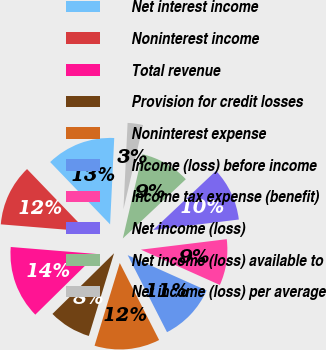<chart> <loc_0><loc_0><loc_500><loc_500><pie_chart><fcel>Net interest income<fcel>Noninterest income<fcel>Total revenue<fcel>Provision for credit losses<fcel>Noninterest expense<fcel>Income (loss) before income<fcel>Income tax expense (benefit)<fcel>Net income (loss)<fcel>Net income (loss) available to<fcel>Net income (loss) per average<nl><fcel>12.95%<fcel>11.51%<fcel>13.67%<fcel>7.91%<fcel>12.23%<fcel>10.79%<fcel>8.63%<fcel>10.07%<fcel>9.35%<fcel>2.88%<nl></chart> 